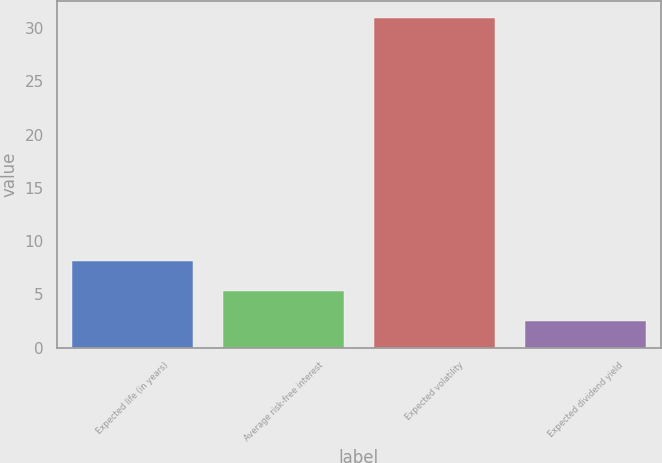Convert chart to OTSL. <chart><loc_0><loc_0><loc_500><loc_500><bar_chart><fcel>Expected life (in years)<fcel>Average risk-free interest<fcel>Expected volatility<fcel>Expected dividend yield<nl><fcel>8.16<fcel>5.31<fcel>31<fcel>2.46<nl></chart> 